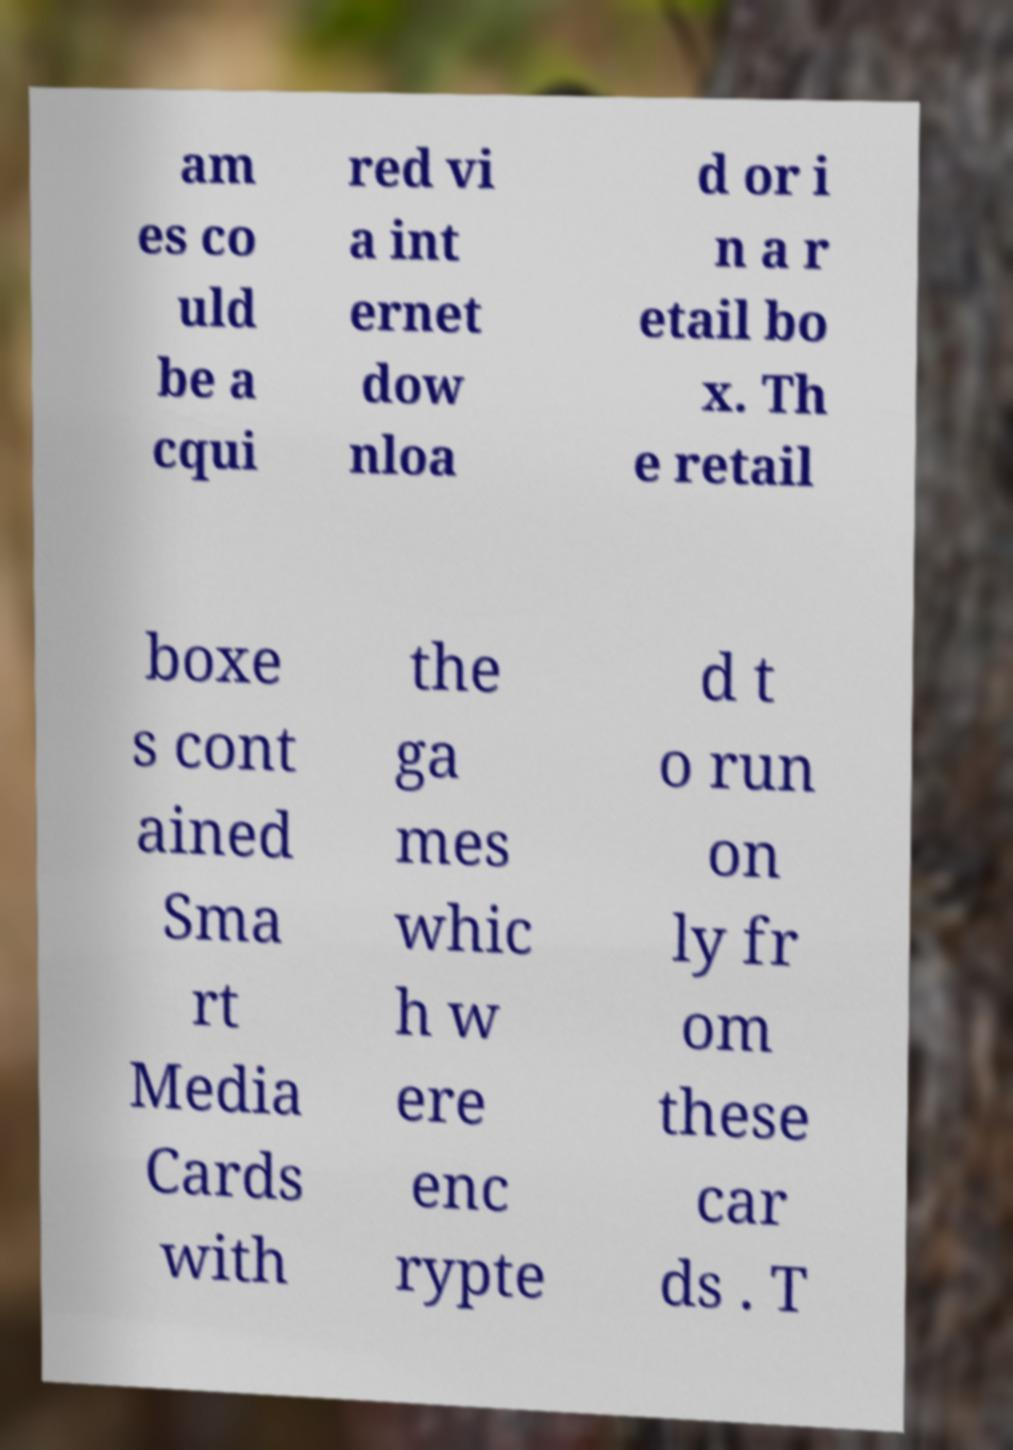For documentation purposes, I need the text within this image transcribed. Could you provide that? am es co uld be a cqui red vi a int ernet dow nloa d or i n a r etail bo x. Th e retail boxe s cont ained Sma rt Media Cards with the ga mes whic h w ere enc rypte d t o run on ly fr om these car ds . T 